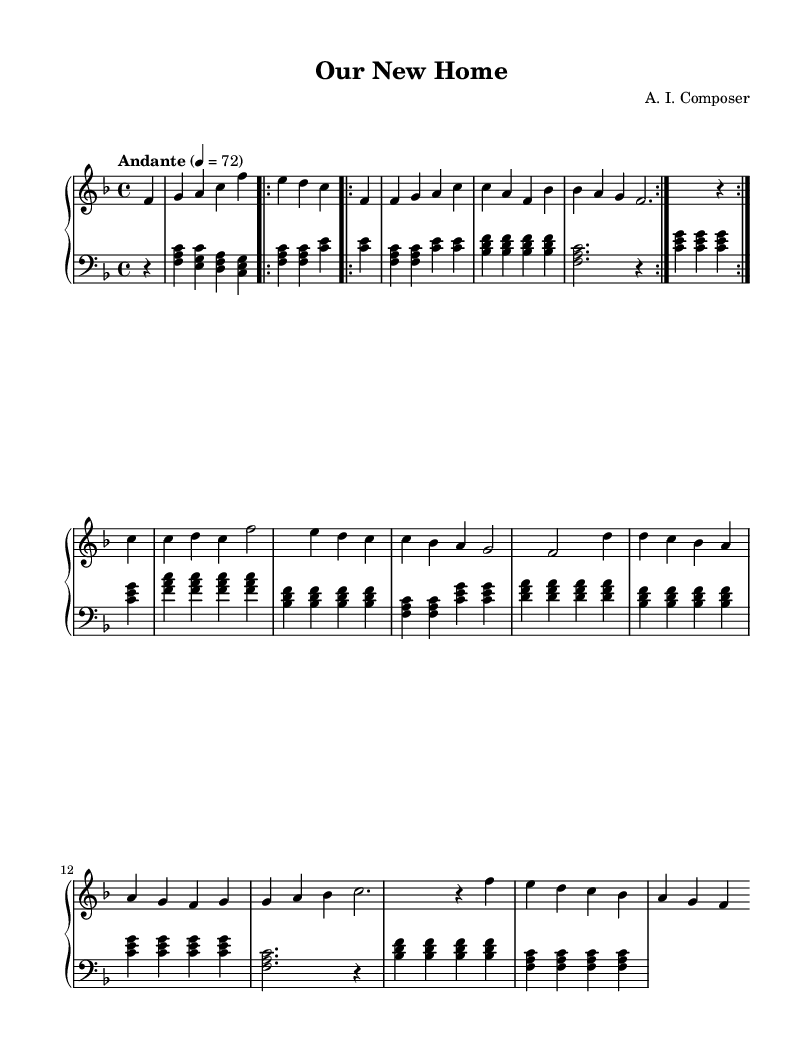What is the key signature of this music? The key signature is F major, indicated by one flat (B flat) in the notation. You can identify the key signature by looking at the beginning of the staff before the first note, where it shows the F major key signature.
Answer: F major What is the time signature of this music? The time signature is 4/4, which means there are four beats in each measure and the quarter note gets one beat. This can be determined by locating the time signature notation at the beginning of the score, right after the key signature.
Answer: 4/4 What is the tempo marking of this piece? The tempo marking is "Andante," indicating a moderately slow tempo. You can find this in the upper section of the score, which specifies the speed at which the piece should be played.
Answer: Andante How many measures are in the chorus section? The chorus section consists of 8 measures. By examining the notation, you can count the measures from the start of the chorus until the section ends, noting that each measure is separated by vertical lines.
Answer: 8 What is the dynamic marking at the beginning of the right hand? The dynamic marking is "p," which stands for piano, meaning to play softly. This marking is found at the beginning of the right-hand part before the introductory notes, indicating the volume level for this section.
Answer: piano Which section of the music contains a repeated part? The verse section contains a repeated part, as indicated by the repeat signs. By looking at the segment of the score, you see the instructions to repeat the specified measures, which is typical in song structures.
Answer: Verse What is the final measure's chord in the left hand? The final measure's chord is B flat major. This can be determined by identifying the notes played in the last measure of the left-hand part and recognizing the chord formed by those notes.
Answer: B flat major 